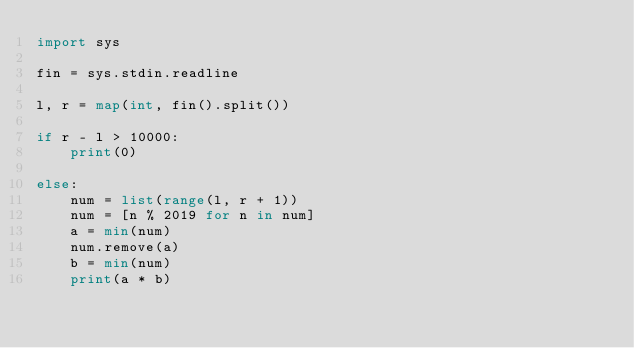<code> <loc_0><loc_0><loc_500><loc_500><_Python_>import sys

fin = sys.stdin.readline

l, r = map(int, fin().split())

if r - l > 10000:
    print(0)

else:
    num = list(range(l, r + 1))
    num = [n % 2019 for n in num]
    a = min(num)
    num.remove(a)
    b = min(num)
    print(a * b)
</code> 